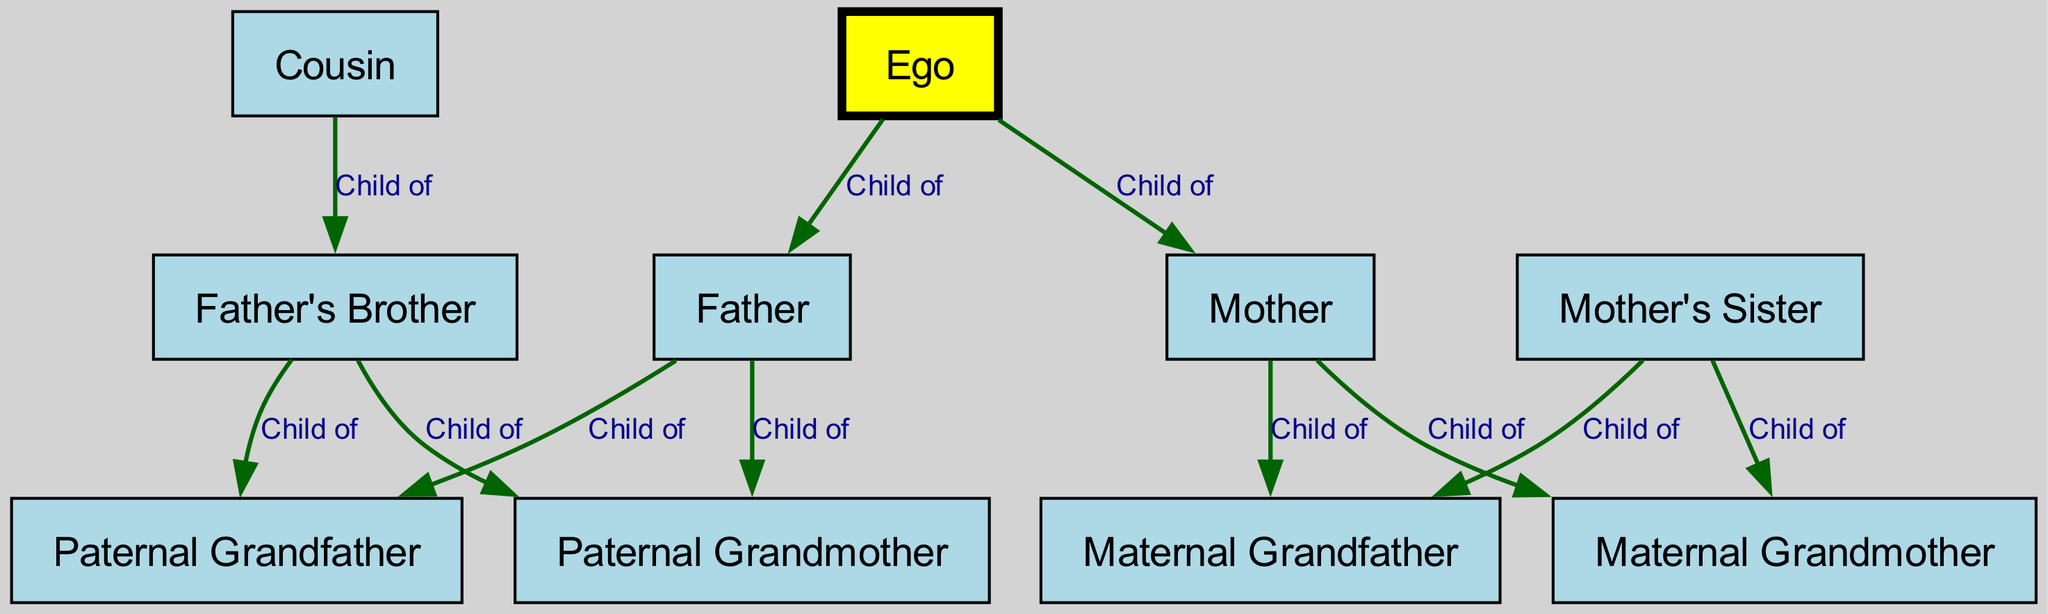What is the label of the node directly connected to Ego labeled as "Father"? The edge from the node labeled "Ego" points to the node labeled "Father" with the relationship "Child of." Therefore, the label of the node directly connected to Ego labeled as "Father" is "Father."
Answer: Father How many total nodes are in the diagram? Counting all unique identifiers in the nodes list, there are 10 nodes including Ego, parents, grandparents, and cousins.
Answer: 10 What is the relationship between Ego and Cousin? The diagram indicates an indirect connection, as Cousin is connected to Father's Brother. Since Father's Brother is indirectly connected to Ego through the Father, the relationship can be determined as "not a direct relationship."
Answer: Not a direct relationship What is the number of edges that connect Ego to his parents? The edges directly connecting Ego are: one to Father and one to Mother, making a total of 2 edges.
Answer: 2 Which node represents the maternal grandmother? The node labeled "Maternal Grandmother" identifies the person's mother’s mother, which is defined in this case as node 7.
Answer: Maternal Grandmother What is the common relationship of Father’s Brother with Paternal Grandfather? The diagram specifies that Father's Brother is a child of Paternal Grandfather, illustrated by an edge connecting both nodes with the label "Child of."
Answer: Child of How many grandparents are present in the diagram? There are four grandparents represented: Paternal Grandfather, Paternal Grandmother, Maternal Grandfather, and Maternal Grandmother, totaling to four.
Answer: 4 What is the relationship type between Mother's Sister and Maternal Grandfather? The edge indicates that Mother's Sister is connected to Maternal Grandfather as a "Child of," signifying a direct lineage.
Answer: Child of Why is the node labeled Ego colored yellow? The node labeled "Ego" is distinguished with a yellow fill color to emphasize its central role in the kinship chart, differentiating it from other family members that are colored light blue.
Answer: Central role 